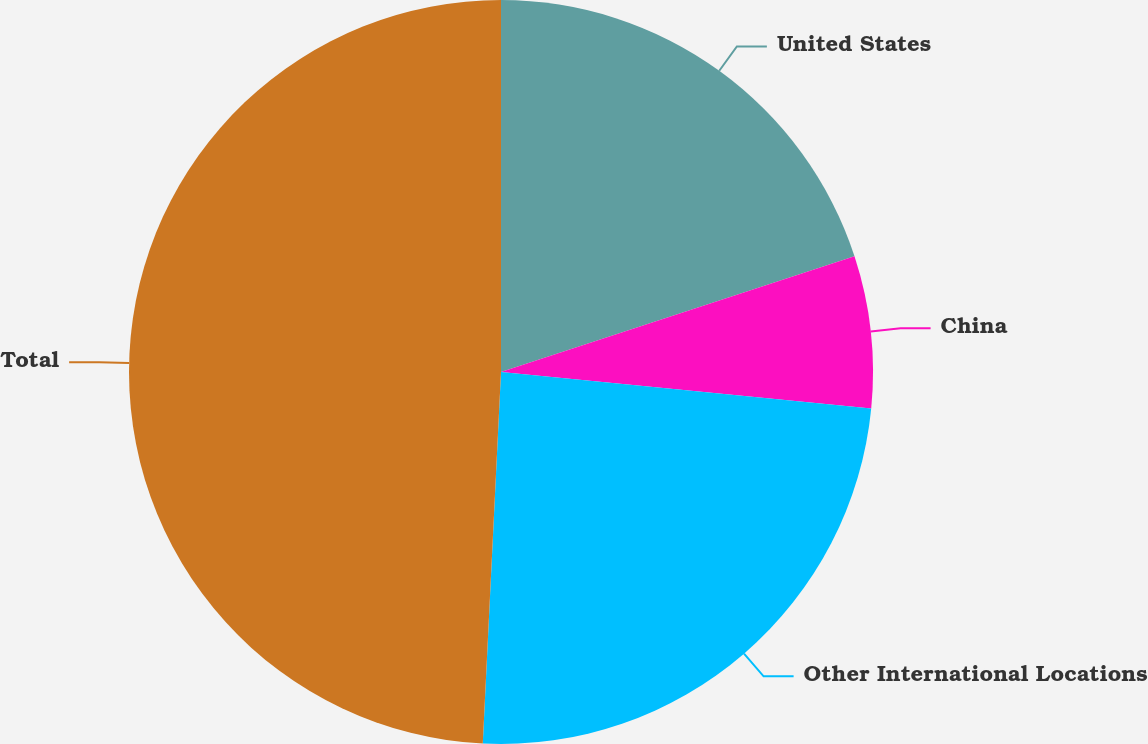Convert chart. <chart><loc_0><loc_0><loc_500><loc_500><pie_chart><fcel>United States<fcel>China<fcel>Other International Locations<fcel>Total<nl><fcel>19.96%<fcel>6.6%<fcel>24.22%<fcel>49.22%<nl></chart> 